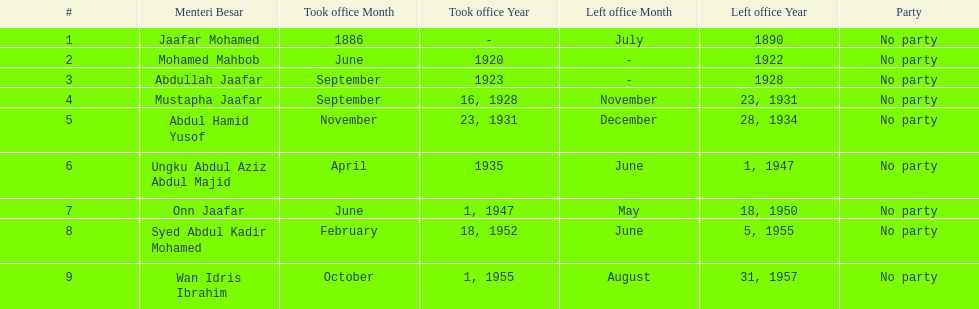Who was in office previous to abdullah jaafar? Mohamed Mahbob. 